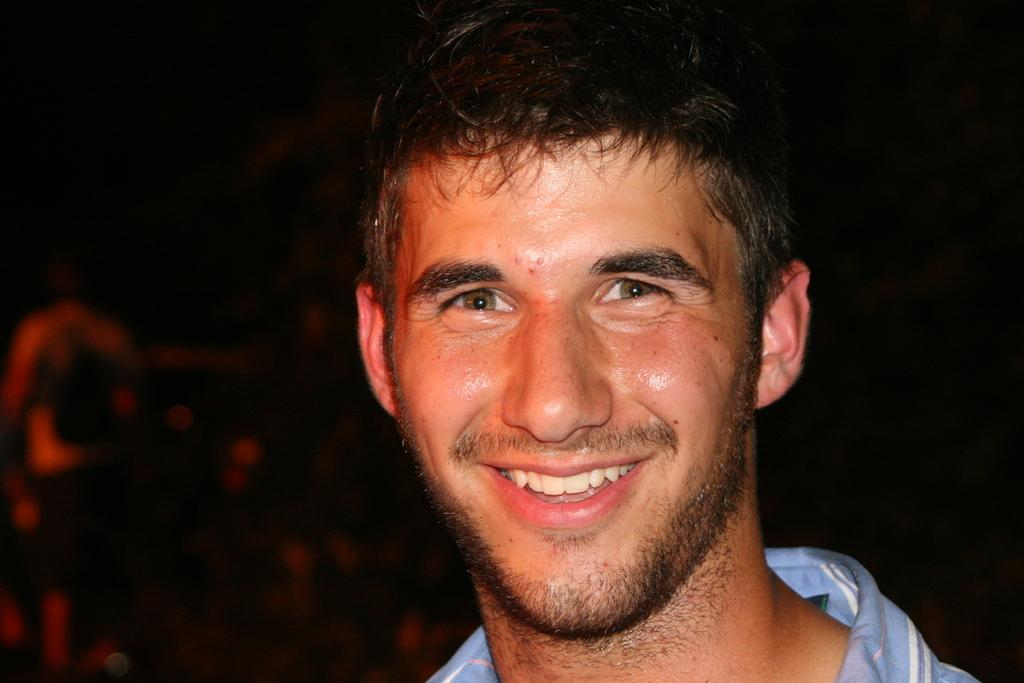What is the main subject in the foreground of the image? There is a man in the foreground of the image. What is the man wearing in the image? The man is wearing a blue shirt in the image. What expression does the man have on his face? The man has a smile on his face in the image. How would you describe the background of the image? The background of the image is dark. What type of bed can be seen in the image? There is no bed present in the image; it features a man in the foreground with a dark background. What is the man eating for breakfast in the image? There is no food, such as oatmeal, visible in the image. 